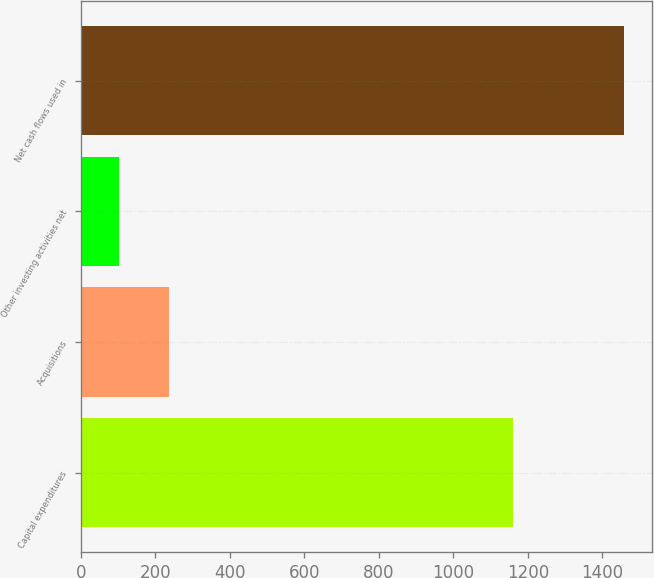Convert chart. <chart><loc_0><loc_0><loc_500><loc_500><bar_chart><fcel>Capital expenditures<fcel>Acquisitions<fcel>Other investing activities net<fcel>Net cash flows used in<nl><fcel>1160<fcel>237.7<fcel>102<fcel>1459<nl></chart> 